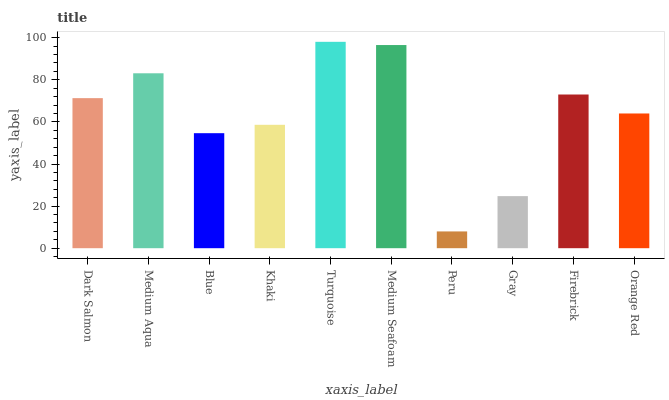Is Medium Aqua the minimum?
Answer yes or no. No. Is Medium Aqua the maximum?
Answer yes or no. No. Is Medium Aqua greater than Dark Salmon?
Answer yes or no. Yes. Is Dark Salmon less than Medium Aqua?
Answer yes or no. Yes. Is Dark Salmon greater than Medium Aqua?
Answer yes or no. No. Is Medium Aqua less than Dark Salmon?
Answer yes or no. No. Is Dark Salmon the high median?
Answer yes or no. Yes. Is Orange Red the low median?
Answer yes or no. Yes. Is Khaki the high median?
Answer yes or no. No. Is Peru the low median?
Answer yes or no. No. 